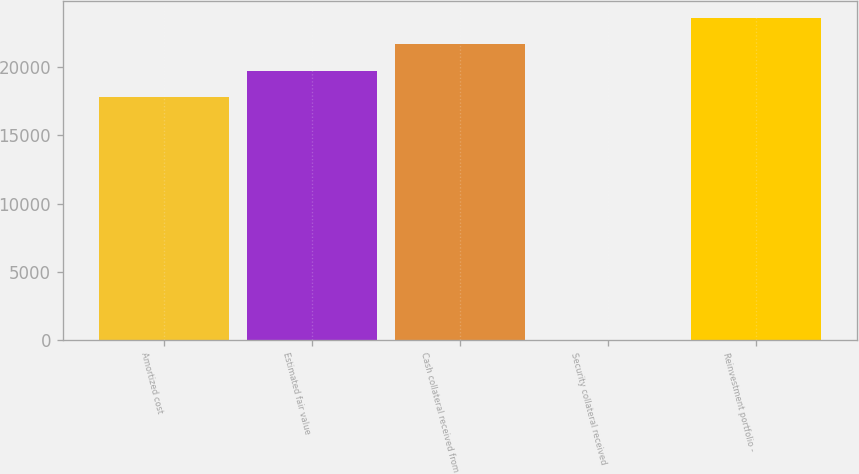Convert chart to OTSL. <chart><loc_0><loc_0><loc_500><loc_500><bar_chart><fcel>Amortized cost<fcel>Estimated fair value<fcel>Cash collateral received from<fcel>Security collateral received<fcel>Reinvestment portfolio -<nl><fcel>17801<fcel>19749.9<fcel>21698.8<fcel>19<fcel>23647.7<nl></chart> 